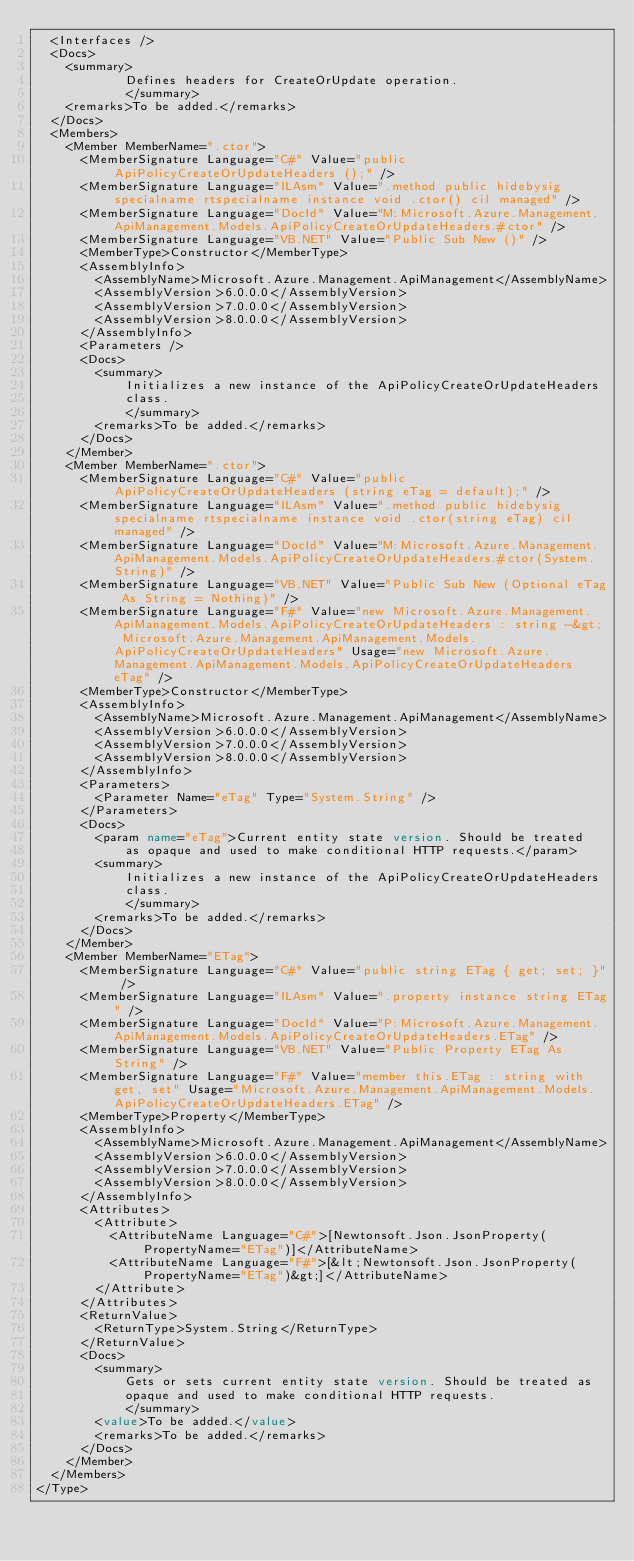Convert code to text. <code><loc_0><loc_0><loc_500><loc_500><_XML_>  <Interfaces />
  <Docs>
    <summary>
            Defines headers for CreateOrUpdate operation.
            </summary>
    <remarks>To be added.</remarks>
  </Docs>
  <Members>
    <Member MemberName=".ctor">
      <MemberSignature Language="C#" Value="public ApiPolicyCreateOrUpdateHeaders ();" />
      <MemberSignature Language="ILAsm" Value=".method public hidebysig specialname rtspecialname instance void .ctor() cil managed" />
      <MemberSignature Language="DocId" Value="M:Microsoft.Azure.Management.ApiManagement.Models.ApiPolicyCreateOrUpdateHeaders.#ctor" />
      <MemberSignature Language="VB.NET" Value="Public Sub New ()" />
      <MemberType>Constructor</MemberType>
      <AssemblyInfo>
        <AssemblyName>Microsoft.Azure.Management.ApiManagement</AssemblyName>
        <AssemblyVersion>6.0.0.0</AssemblyVersion>
        <AssemblyVersion>7.0.0.0</AssemblyVersion>
        <AssemblyVersion>8.0.0.0</AssemblyVersion>
      </AssemblyInfo>
      <Parameters />
      <Docs>
        <summary>
            Initializes a new instance of the ApiPolicyCreateOrUpdateHeaders
            class.
            </summary>
        <remarks>To be added.</remarks>
      </Docs>
    </Member>
    <Member MemberName=".ctor">
      <MemberSignature Language="C#" Value="public ApiPolicyCreateOrUpdateHeaders (string eTag = default);" />
      <MemberSignature Language="ILAsm" Value=".method public hidebysig specialname rtspecialname instance void .ctor(string eTag) cil managed" />
      <MemberSignature Language="DocId" Value="M:Microsoft.Azure.Management.ApiManagement.Models.ApiPolicyCreateOrUpdateHeaders.#ctor(System.String)" />
      <MemberSignature Language="VB.NET" Value="Public Sub New (Optional eTag As String = Nothing)" />
      <MemberSignature Language="F#" Value="new Microsoft.Azure.Management.ApiManagement.Models.ApiPolicyCreateOrUpdateHeaders : string -&gt; Microsoft.Azure.Management.ApiManagement.Models.ApiPolicyCreateOrUpdateHeaders" Usage="new Microsoft.Azure.Management.ApiManagement.Models.ApiPolicyCreateOrUpdateHeaders eTag" />
      <MemberType>Constructor</MemberType>
      <AssemblyInfo>
        <AssemblyName>Microsoft.Azure.Management.ApiManagement</AssemblyName>
        <AssemblyVersion>6.0.0.0</AssemblyVersion>
        <AssemblyVersion>7.0.0.0</AssemblyVersion>
        <AssemblyVersion>8.0.0.0</AssemblyVersion>
      </AssemblyInfo>
      <Parameters>
        <Parameter Name="eTag" Type="System.String" />
      </Parameters>
      <Docs>
        <param name="eTag">Current entity state version. Should be treated
            as opaque and used to make conditional HTTP requests.</param>
        <summary>
            Initializes a new instance of the ApiPolicyCreateOrUpdateHeaders
            class.
            </summary>
        <remarks>To be added.</remarks>
      </Docs>
    </Member>
    <Member MemberName="ETag">
      <MemberSignature Language="C#" Value="public string ETag { get; set; }" />
      <MemberSignature Language="ILAsm" Value=".property instance string ETag" />
      <MemberSignature Language="DocId" Value="P:Microsoft.Azure.Management.ApiManagement.Models.ApiPolicyCreateOrUpdateHeaders.ETag" />
      <MemberSignature Language="VB.NET" Value="Public Property ETag As String" />
      <MemberSignature Language="F#" Value="member this.ETag : string with get, set" Usage="Microsoft.Azure.Management.ApiManagement.Models.ApiPolicyCreateOrUpdateHeaders.ETag" />
      <MemberType>Property</MemberType>
      <AssemblyInfo>
        <AssemblyName>Microsoft.Azure.Management.ApiManagement</AssemblyName>
        <AssemblyVersion>6.0.0.0</AssemblyVersion>
        <AssemblyVersion>7.0.0.0</AssemblyVersion>
        <AssemblyVersion>8.0.0.0</AssemblyVersion>
      </AssemblyInfo>
      <Attributes>
        <Attribute>
          <AttributeName Language="C#">[Newtonsoft.Json.JsonProperty(PropertyName="ETag")]</AttributeName>
          <AttributeName Language="F#">[&lt;Newtonsoft.Json.JsonProperty(PropertyName="ETag")&gt;]</AttributeName>
        </Attribute>
      </Attributes>
      <ReturnValue>
        <ReturnType>System.String</ReturnType>
      </ReturnValue>
      <Docs>
        <summary>
            Gets or sets current entity state version. Should be treated as
            opaque and used to make conditional HTTP requests.
            </summary>
        <value>To be added.</value>
        <remarks>To be added.</remarks>
      </Docs>
    </Member>
  </Members>
</Type>
</code> 